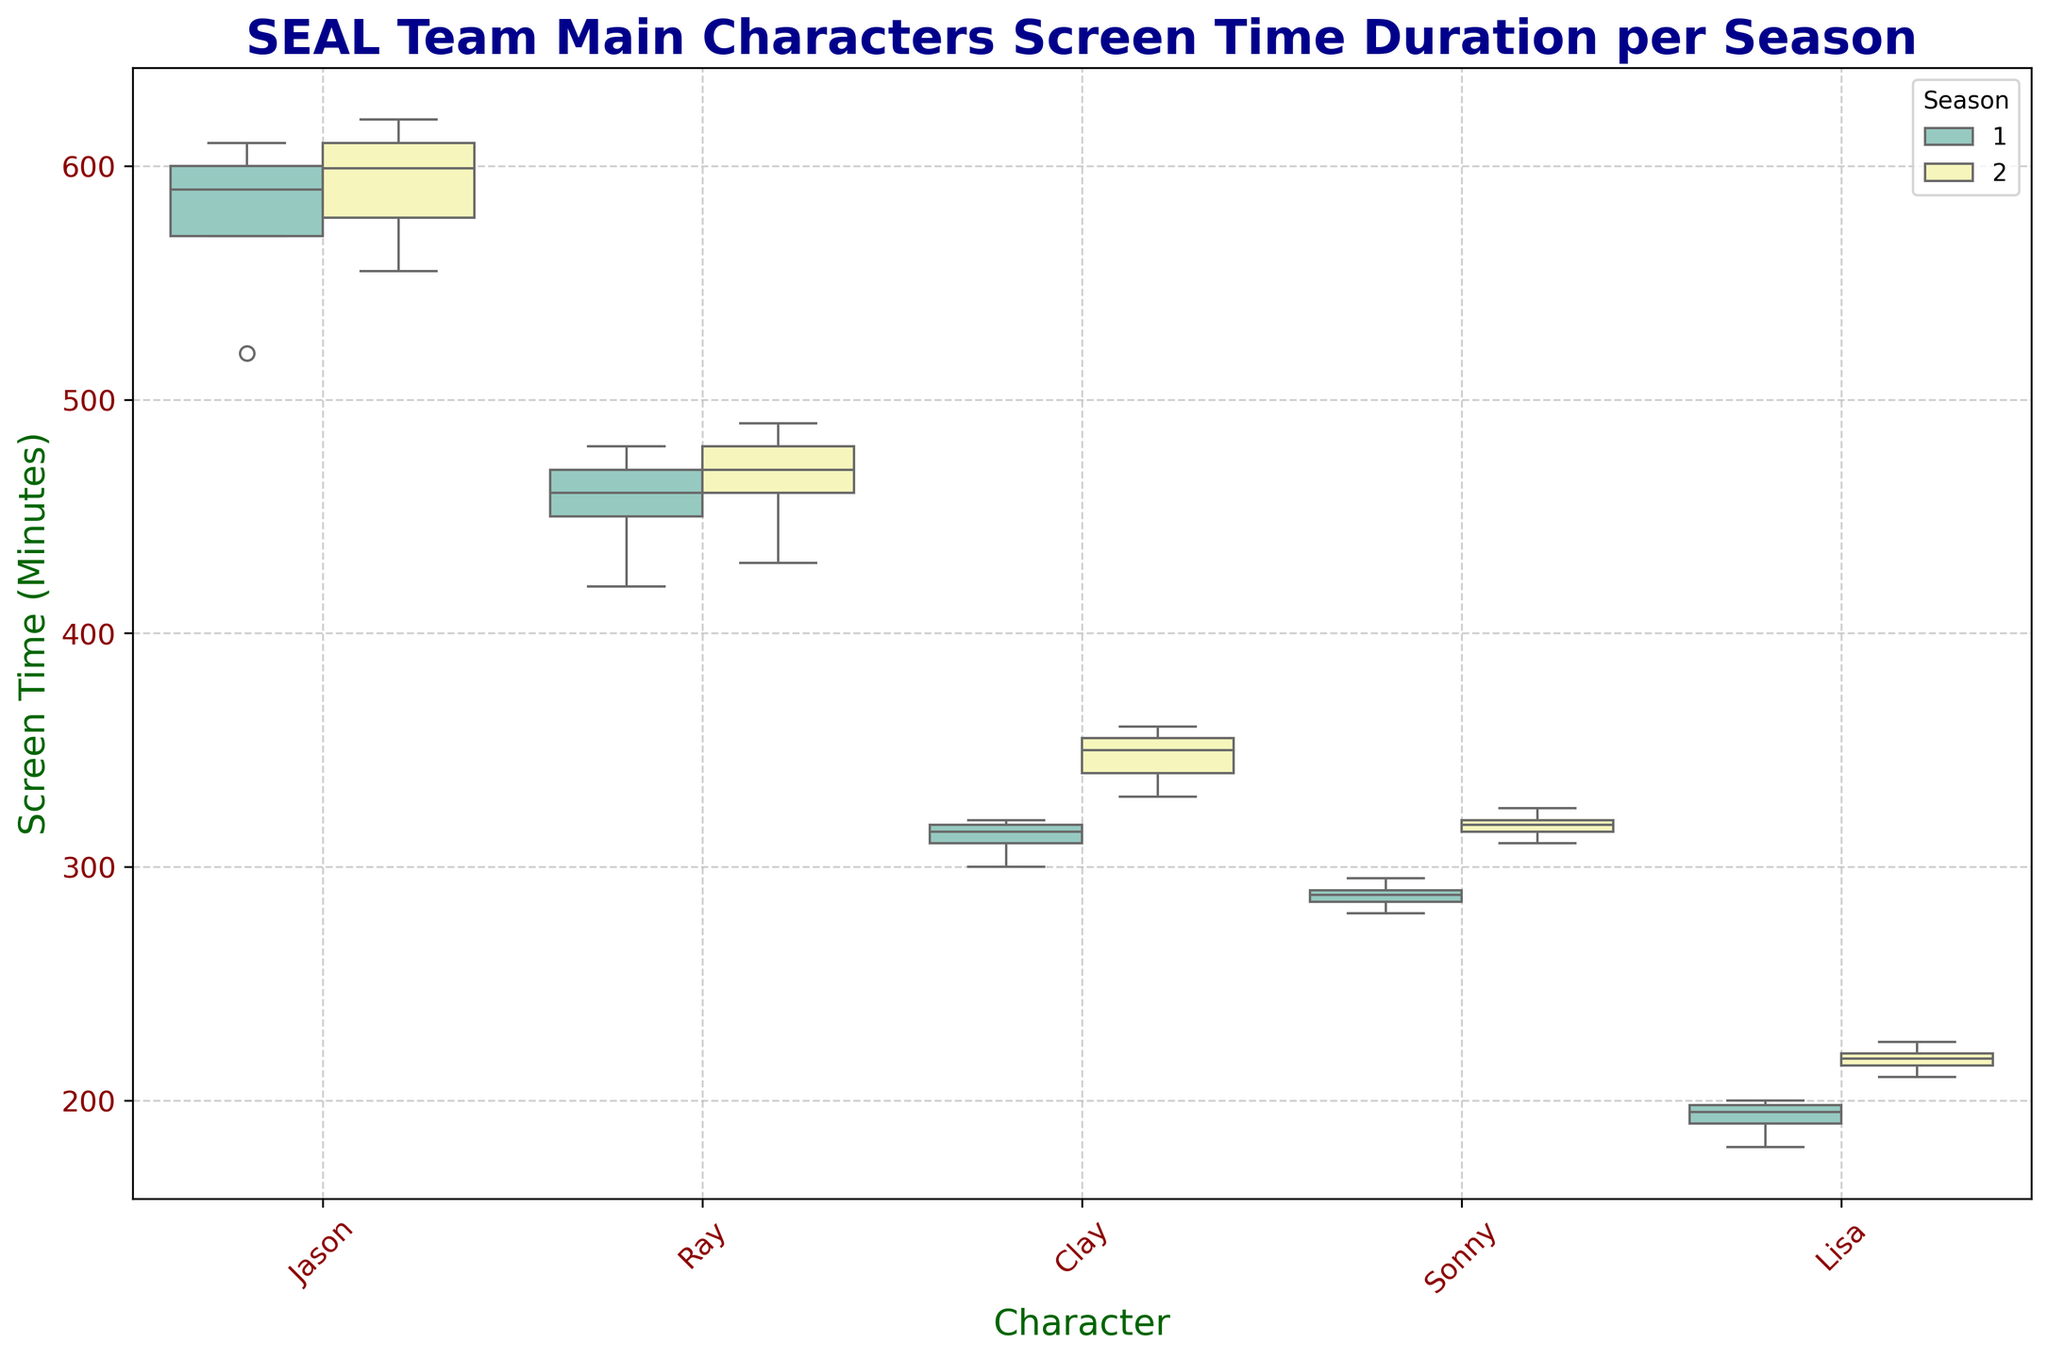What is the median screen time for Jason in Season 1? Look at the box plot for Jason in Season 1. The central line inside the box represents the median value.
Answer: 590 Which character has higher variability in screen time in Season 2, Ray or Clay? Variability can be assessed by the interquartile range (IQR), which is the length of the box. Compare the lengths of the boxes for Ray and Clay in Season 2.
Answer: Ray Who had more median screen time in Season 1, Sonny or Clay? Find the central line inside the boxes for Sonny and Clay in Season 1 and compare their heights.
Answer: Clay Which character had the least median screen time in Season 2? Compare the medians (central lines in the boxes) for all characters in Season 2.
Answer: Lisa Was the median screen time for Jason higher in Season 1 or Season 2? Compare the central lines inside the two boxes for Jason in Seasons 1 and 2.
Answer: Season 2 Which season had a wider range of screen times for Lisa? The range is determined by the distance between the minimum and maximum whiskers. Compare these ranges for Lisa in both seasons.
Answer: Season 2 What is the approximate interquartile range (IQR) for Sonny in Season 1? The IQR is the length of the box, representing the distance between the first quartile (bottom of the box) and the third quartile (top of the box). Estimate this length from the plot.
Answer: 10 minutes How do the median screen times for Ray and Sonny in Season 1 compare? Compare the central lines inside the boxes for Ray and Sonny in Season 1 to determine which is higher.
Answer: Ray Which character has the smallest range in screen time in Season 2? Compare the lengths of the whiskers (minimum to maximum values) for all characters in Season 2.
Answer: Sonny How does Lisa's median screen time in Season 1 compare with her median screen time in Season 2? Compare the central lines inside the boxes for Lisa in Seasons 1 and 2.
Answer: Season 2 is higher 